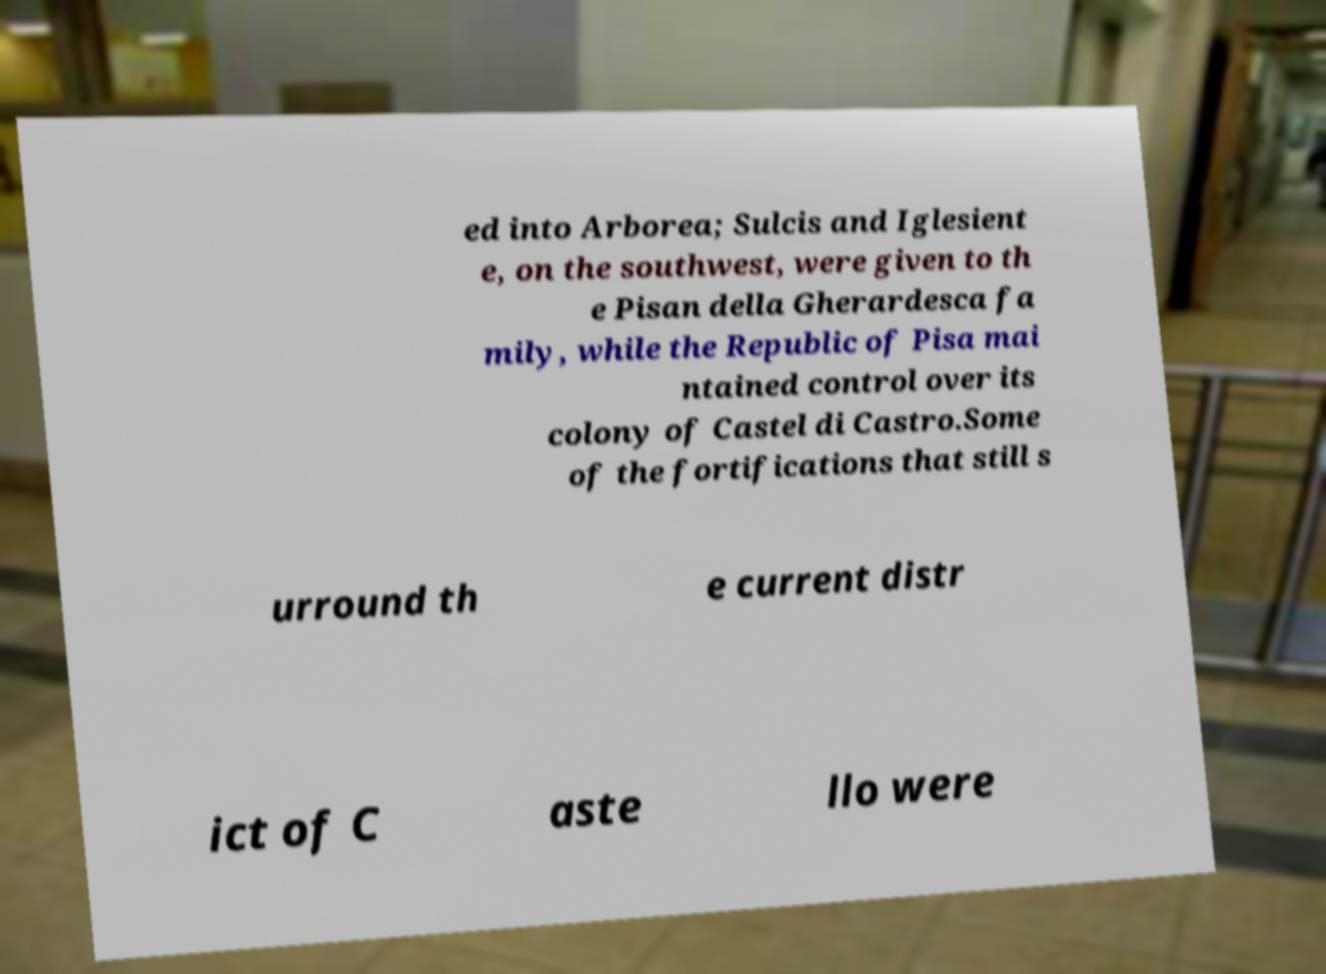Can you accurately transcribe the text from the provided image for me? ed into Arborea; Sulcis and Iglesient e, on the southwest, were given to th e Pisan della Gherardesca fa mily, while the Republic of Pisa mai ntained control over its colony of Castel di Castro.Some of the fortifications that still s urround th e current distr ict of C aste llo were 